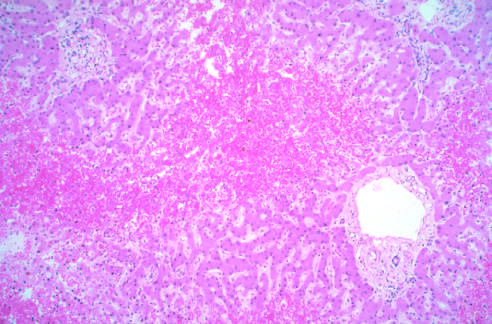re atrophied hepatocytes not easily seen?
Answer the question using a single word or phrase. Yes 